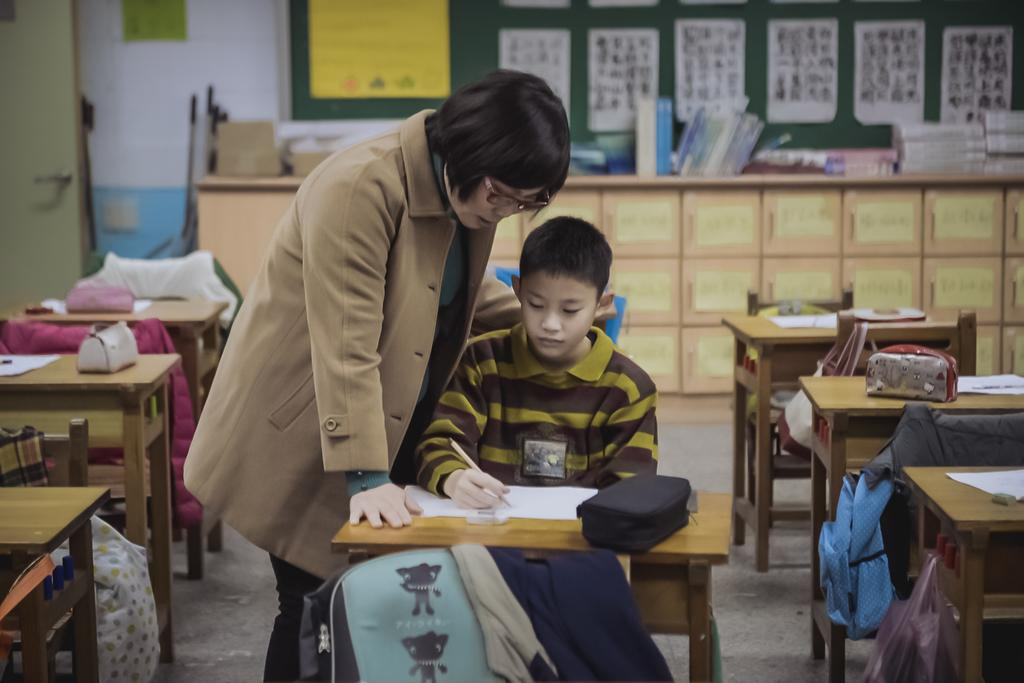Who are the people in the image? There is a woman and a boy in the image. What are the positions of the woman and the boy in the image? The woman is standing, and the boy is sitting on a chair. What is the boy doing in the image? The boy is writing on a book. Where is the book located in the image? The book is on a table. What is the setting of the image? The setting appears to be a classroom. What type of voyage is the woman planning in the image? There is no indication of a voyage in the image; it depicts a woman and a boy in a classroom setting. What is the relation between the woman and the boy in the image? The relation between the woman and the boy is not specified in the image. 